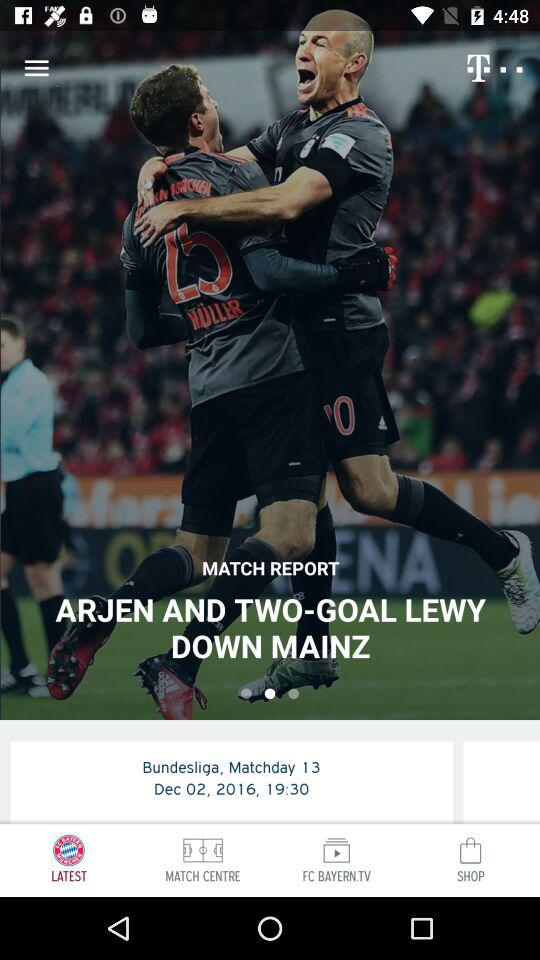What is the matchday? The matchday is 13. 